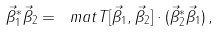Convert formula to latex. <formula><loc_0><loc_0><loc_500><loc_500>\vec { \beta } _ { 1 } ^ { * } \vec { \beta } _ { 2 } = \ m a t { T } [ \vec { \beta } _ { 1 } , \vec { \beta } _ { 2 } ] \cdot ( \vec { \beta } _ { 2 } ^ { * } \vec { \beta } _ { 1 } ) \, ,</formula> 